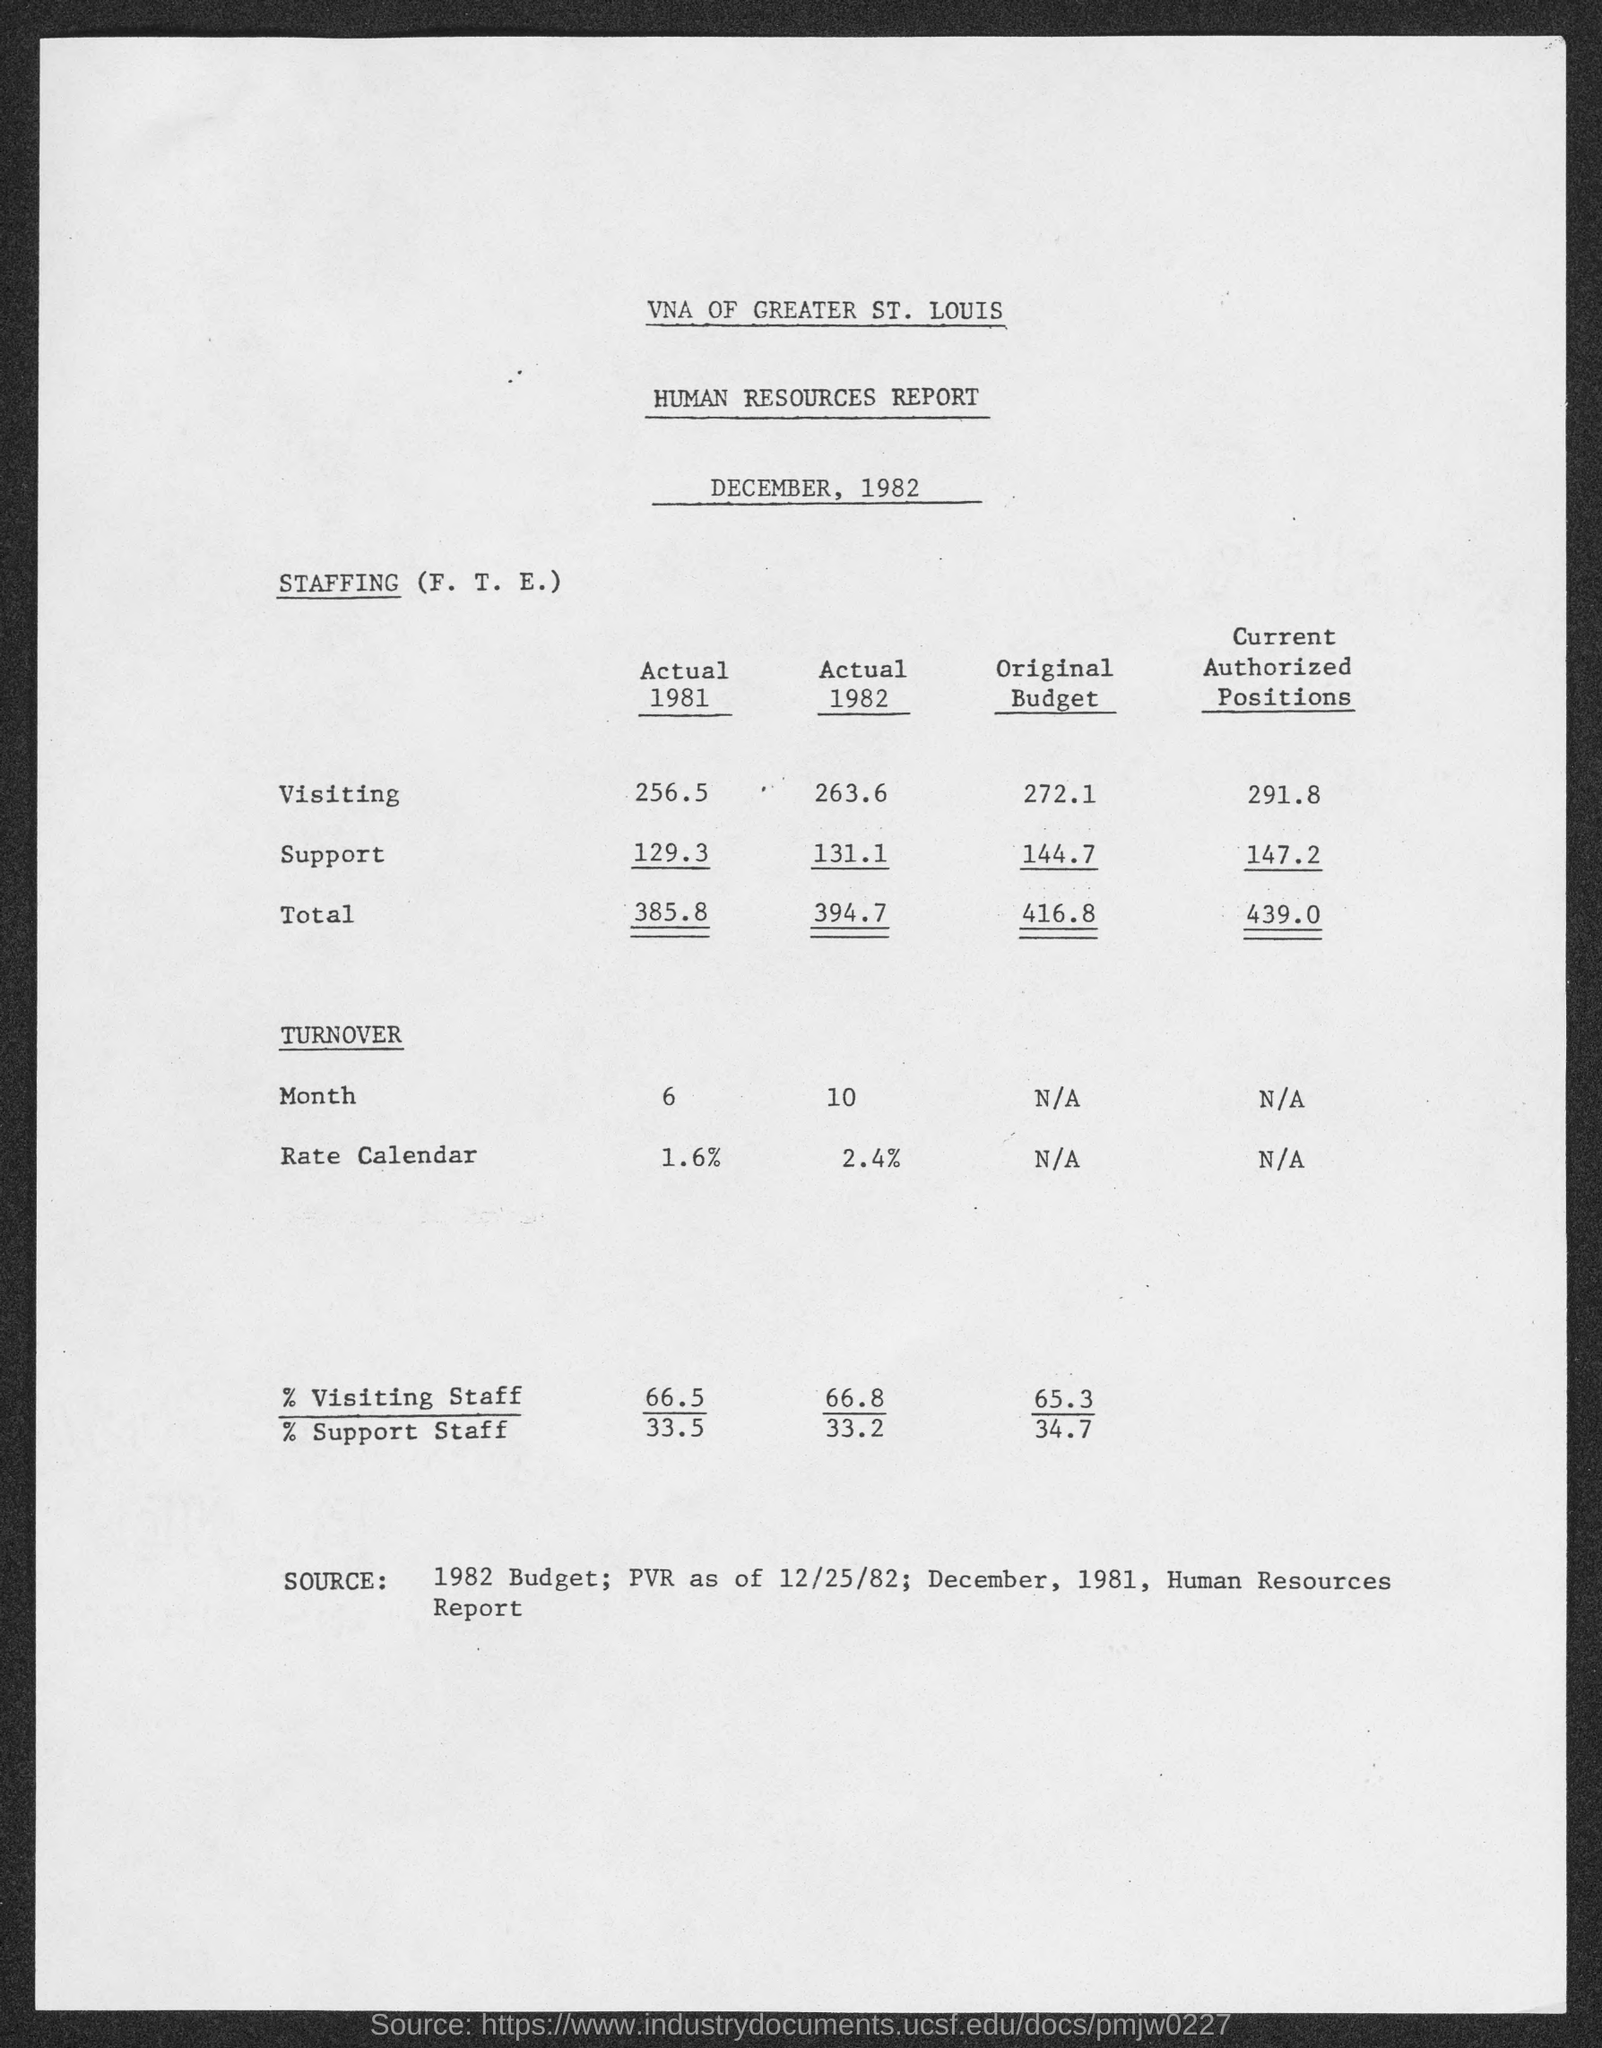What is the first title in the document?
Offer a terse response. VNA of Greater St. Louis. What is the second title in the document?
Make the answer very short. Human Resources Report. What is the percentage of visiting staff in the year 1981?
Give a very brief answer. 66.5. What is the percentage of support staff in the year 1981?
Give a very brief answer. 33.5. 